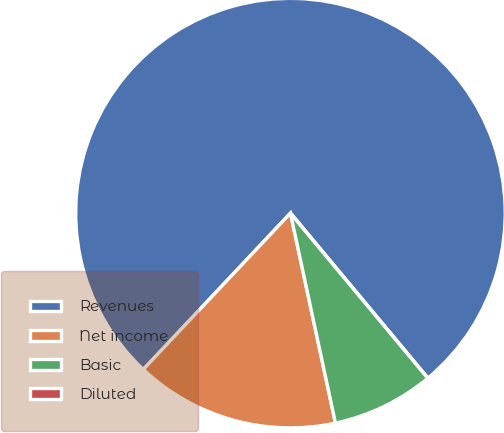Convert chart. <chart><loc_0><loc_0><loc_500><loc_500><pie_chart><fcel>Revenues<fcel>Net income<fcel>Basic<fcel>Diluted<nl><fcel>76.92%<fcel>15.38%<fcel>7.69%<fcel>0.0%<nl></chart> 